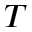Convert formula to latex. <formula><loc_0><loc_0><loc_500><loc_500>^ { T }</formula> 